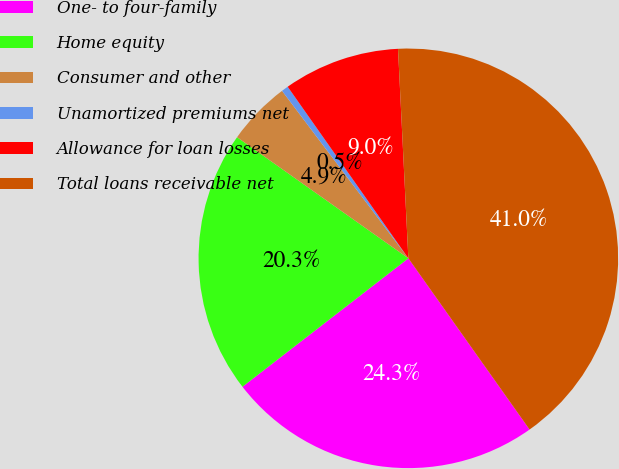<chart> <loc_0><loc_0><loc_500><loc_500><pie_chart><fcel>One- to four-family<fcel>Home equity<fcel>Consumer and other<fcel>Unamortized premiums net<fcel>Allowance for loan losses<fcel>Total loans receivable net<nl><fcel>24.32%<fcel>20.28%<fcel>4.92%<fcel>0.53%<fcel>8.97%<fcel>40.98%<nl></chart> 